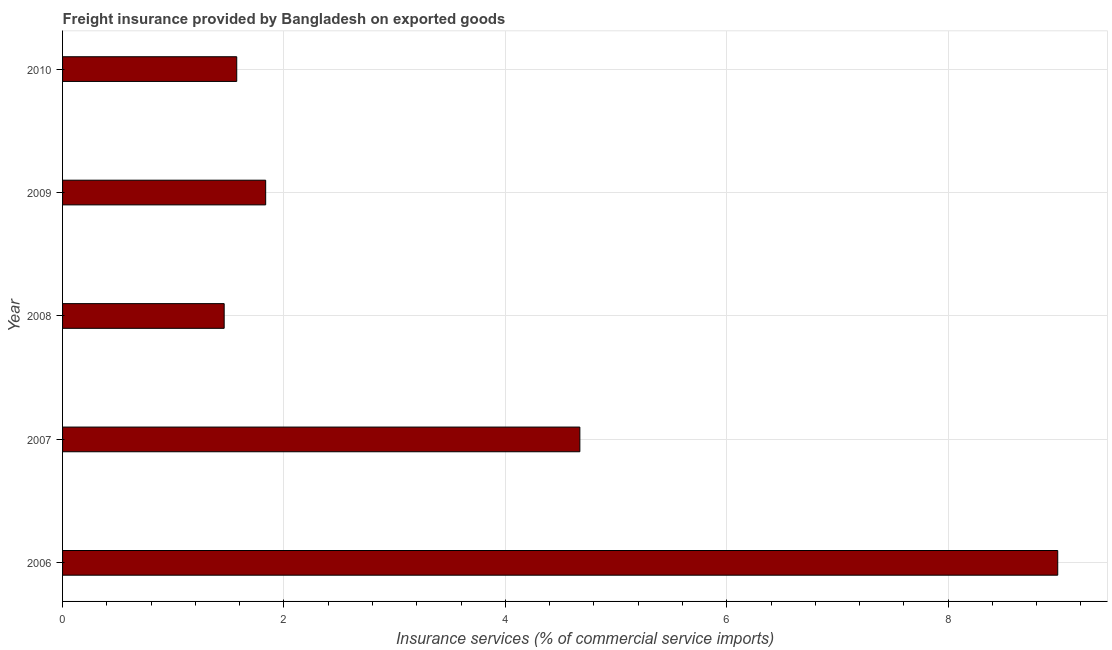Does the graph contain grids?
Provide a short and direct response. Yes. What is the title of the graph?
Your answer should be compact. Freight insurance provided by Bangladesh on exported goods . What is the label or title of the X-axis?
Give a very brief answer. Insurance services (% of commercial service imports). What is the label or title of the Y-axis?
Provide a short and direct response. Year. What is the freight insurance in 2009?
Provide a short and direct response. 1.83. Across all years, what is the maximum freight insurance?
Your response must be concise. 8.99. Across all years, what is the minimum freight insurance?
Keep it short and to the point. 1.46. In which year was the freight insurance maximum?
Your response must be concise. 2006. What is the sum of the freight insurance?
Offer a very short reply. 18.53. What is the difference between the freight insurance in 2006 and 2009?
Offer a very short reply. 7.16. What is the average freight insurance per year?
Your answer should be compact. 3.71. What is the median freight insurance?
Your answer should be very brief. 1.83. In how many years, is the freight insurance greater than 4.8 %?
Your answer should be very brief. 1. What is the ratio of the freight insurance in 2007 to that in 2009?
Your answer should be compact. 2.55. Is the freight insurance in 2007 less than that in 2008?
Provide a short and direct response. No. What is the difference between the highest and the second highest freight insurance?
Offer a terse response. 4.32. Is the sum of the freight insurance in 2006 and 2009 greater than the maximum freight insurance across all years?
Offer a terse response. Yes. What is the difference between the highest and the lowest freight insurance?
Provide a succinct answer. 7.53. How many bars are there?
Your answer should be very brief. 5. Are all the bars in the graph horizontal?
Give a very brief answer. Yes. What is the difference between two consecutive major ticks on the X-axis?
Your response must be concise. 2. What is the Insurance services (% of commercial service imports) in 2006?
Your response must be concise. 8.99. What is the Insurance services (% of commercial service imports) of 2007?
Give a very brief answer. 4.67. What is the Insurance services (% of commercial service imports) of 2008?
Provide a succinct answer. 1.46. What is the Insurance services (% of commercial service imports) of 2009?
Make the answer very short. 1.83. What is the Insurance services (% of commercial service imports) of 2010?
Provide a succinct answer. 1.57. What is the difference between the Insurance services (% of commercial service imports) in 2006 and 2007?
Keep it short and to the point. 4.32. What is the difference between the Insurance services (% of commercial service imports) in 2006 and 2008?
Provide a succinct answer. 7.53. What is the difference between the Insurance services (% of commercial service imports) in 2006 and 2009?
Your answer should be very brief. 7.16. What is the difference between the Insurance services (% of commercial service imports) in 2006 and 2010?
Ensure brevity in your answer.  7.42. What is the difference between the Insurance services (% of commercial service imports) in 2007 and 2008?
Offer a terse response. 3.21. What is the difference between the Insurance services (% of commercial service imports) in 2007 and 2009?
Your answer should be compact. 2.84. What is the difference between the Insurance services (% of commercial service imports) in 2007 and 2010?
Give a very brief answer. 3.1. What is the difference between the Insurance services (% of commercial service imports) in 2008 and 2009?
Provide a short and direct response. -0.37. What is the difference between the Insurance services (% of commercial service imports) in 2008 and 2010?
Make the answer very short. -0.11. What is the difference between the Insurance services (% of commercial service imports) in 2009 and 2010?
Your answer should be compact. 0.26. What is the ratio of the Insurance services (% of commercial service imports) in 2006 to that in 2007?
Your response must be concise. 1.92. What is the ratio of the Insurance services (% of commercial service imports) in 2006 to that in 2008?
Offer a very short reply. 6.16. What is the ratio of the Insurance services (% of commercial service imports) in 2006 to that in 2010?
Give a very brief answer. 5.71. What is the ratio of the Insurance services (% of commercial service imports) in 2007 to that in 2008?
Provide a succinct answer. 3.2. What is the ratio of the Insurance services (% of commercial service imports) in 2007 to that in 2009?
Offer a terse response. 2.55. What is the ratio of the Insurance services (% of commercial service imports) in 2007 to that in 2010?
Ensure brevity in your answer.  2.97. What is the ratio of the Insurance services (% of commercial service imports) in 2008 to that in 2009?
Your answer should be compact. 0.8. What is the ratio of the Insurance services (% of commercial service imports) in 2008 to that in 2010?
Offer a very short reply. 0.93. What is the ratio of the Insurance services (% of commercial service imports) in 2009 to that in 2010?
Provide a short and direct response. 1.17. 